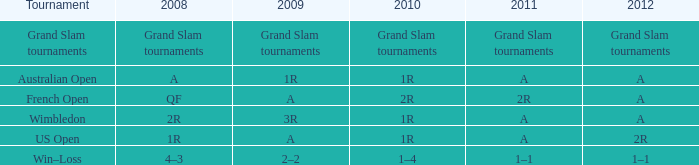What is the name of the tournament with a 2r classification in 2011? French Open. 